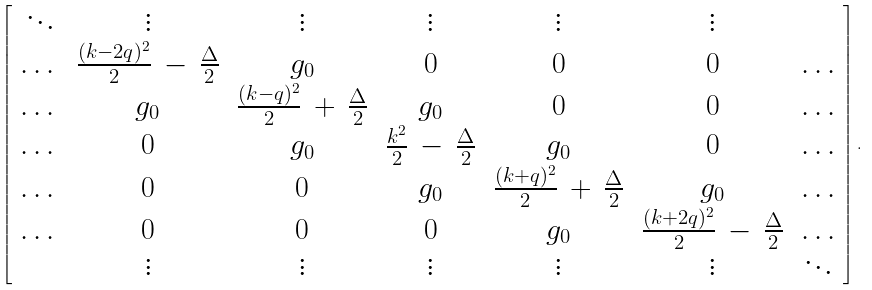Convert formula to latex. <formula><loc_0><loc_0><loc_500><loc_500>\left [ \begin{array} { c c c c c c c } \ddots & \vdots & \vdots & \vdots & \vdots & \vdots & \\ \dots & \frac { ( k - 2 q ) ^ { 2 } } { 2 } \, - \, \frac { \Delta } { 2 } & g _ { 0 } & 0 & 0 & 0 & \dots \\ \dots & g _ { 0 } & \frac { ( k - q ) ^ { 2 } } { 2 } \, + \, \frac { \Delta } { 2 } & g _ { 0 } & 0 & 0 & \dots \\ \dots & 0 & g _ { 0 } & \frac { k ^ { 2 } } { 2 } \, - \, \frac { \Delta } { 2 } & g _ { 0 } & 0 & \dots \\ \dots & 0 & 0 & g _ { 0 } & \frac { ( k + q ) ^ { 2 } } { 2 } \, + \, \frac { \Delta } { 2 } & g _ { 0 } & \dots \\ \dots & 0 & 0 & 0 & g _ { 0 } & \frac { ( k + 2 q ) ^ { 2 } } { 2 } \, - \, \frac { \Delta } { 2 } & \dots \\ & \vdots & \vdots & \vdots & \vdots & \vdots & \ddots \end{array} \right ] .</formula> 